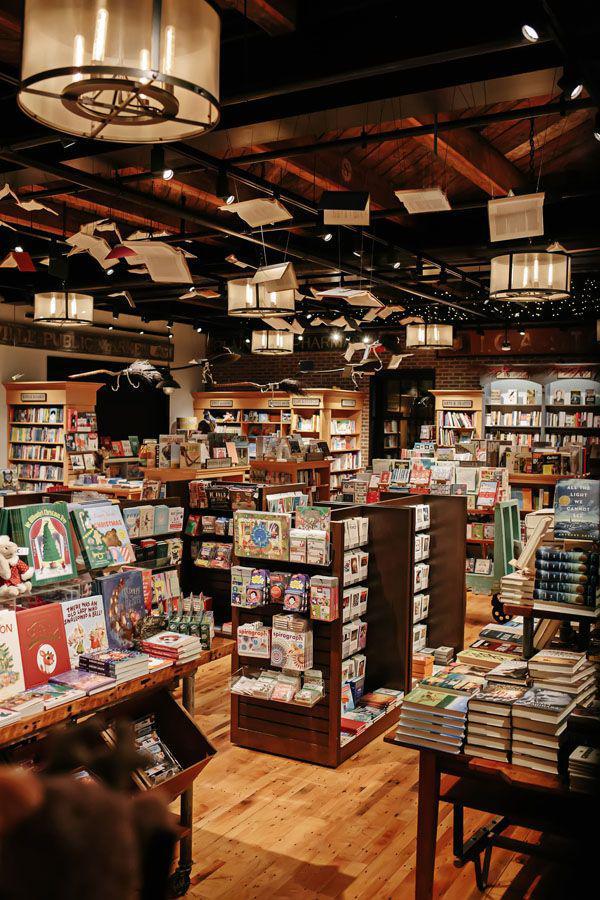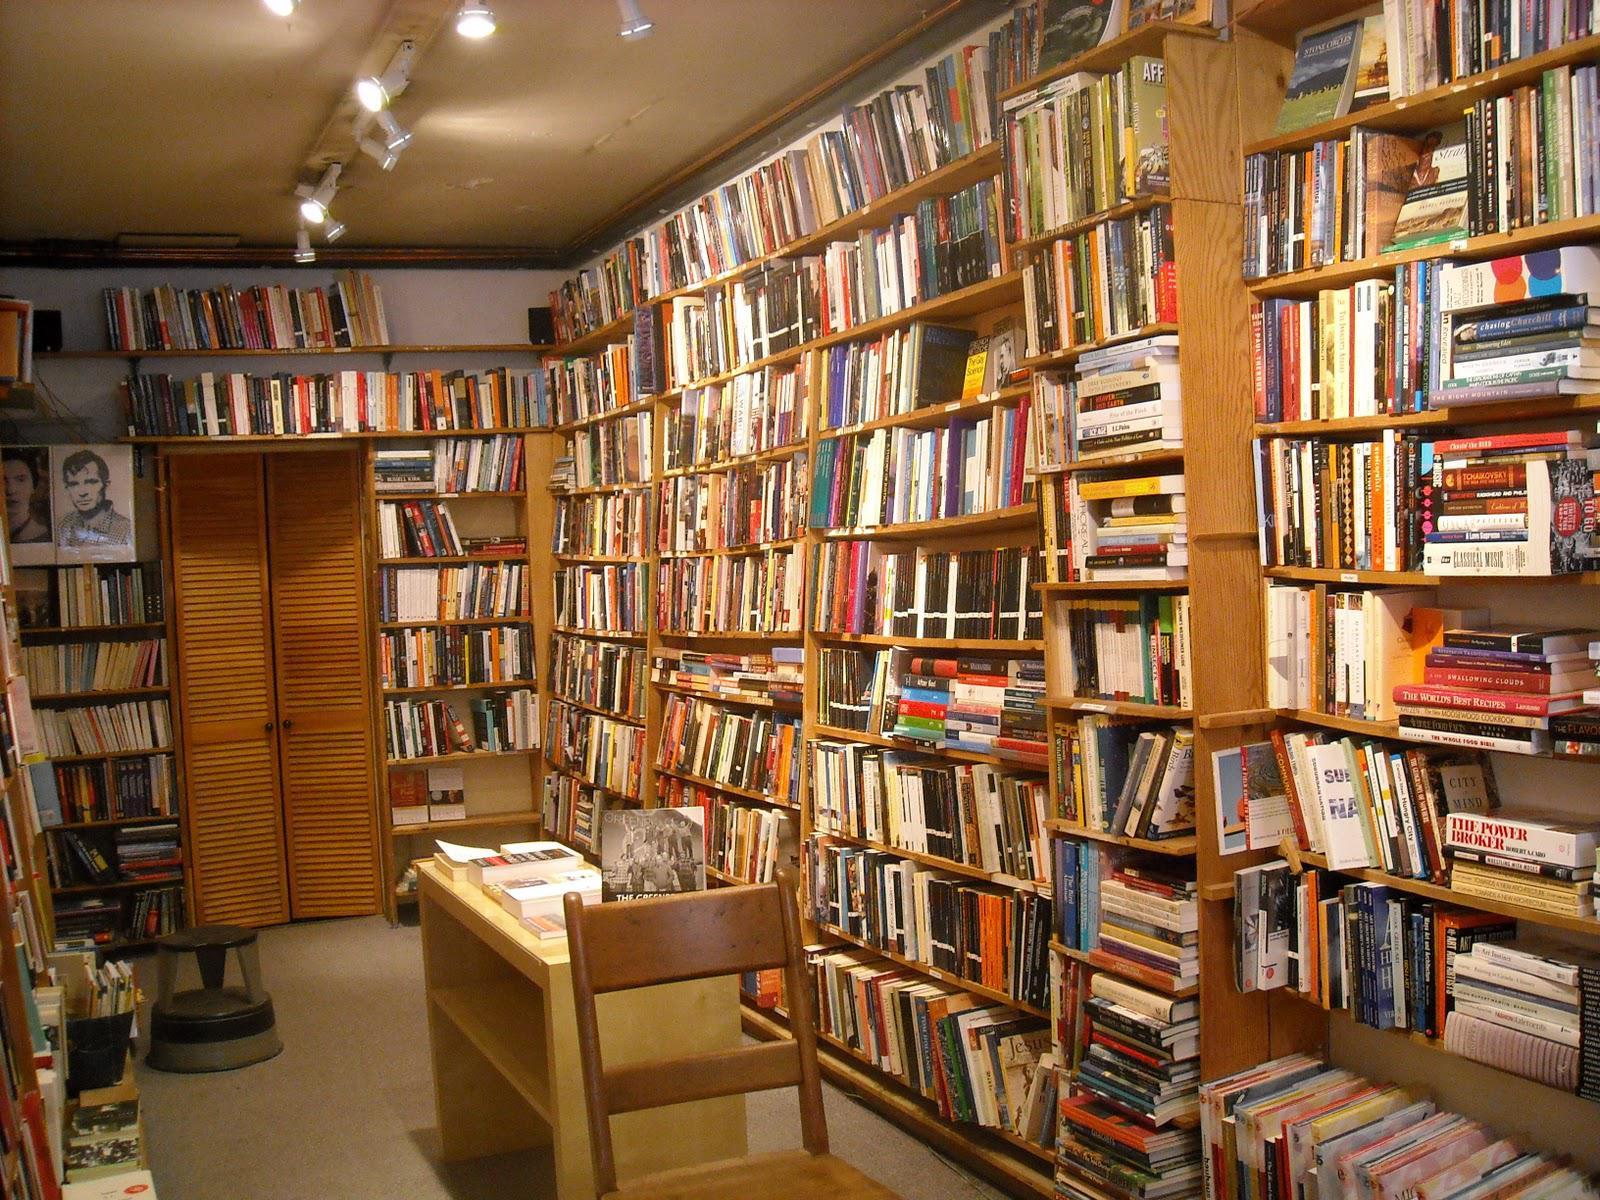The first image is the image on the left, the second image is the image on the right. Assess this claim about the two images: "One image is the interior of a bookshop and one image is the exterior of a bookshop.". Correct or not? Answer yes or no. No. The first image is the image on the left, the second image is the image on the right. Evaluate the accuracy of this statement regarding the images: "The right image shows the exterior of a bookshop.". Is it true? Answer yes or no. No. 